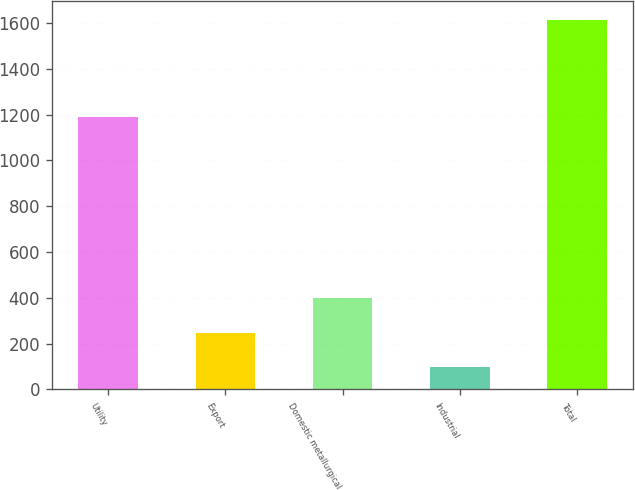Convert chart to OTSL. <chart><loc_0><loc_0><loc_500><loc_500><bar_chart><fcel>Utility<fcel>Export<fcel>Domestic metallurgical<fcel>Industrial<fcel>Total<nl><fcel>1188.5<fcel>247.68<fcel>399.56<fcel>95.8<fcel>1614.6<nl></chart> 